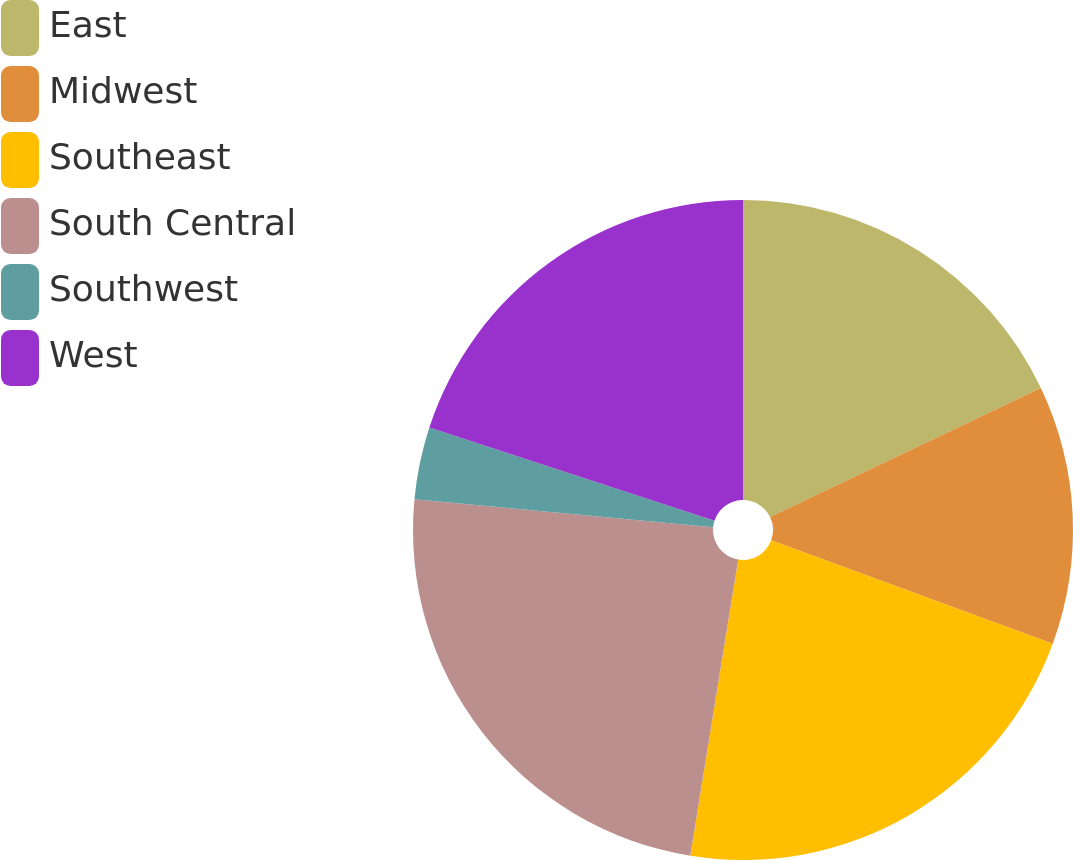Convert chart to OTSL. <chart><loc_0><loc_0><loc_500><loc_500><pie_chart><fcel>East<fcel>Midwest<fcel>Southeast<fcel>South Central<fcel>Southwest<fcel>West<nl><fcel>17.92%<fcel>12.69%<fcel>21.95%<fcel>23.93%<fcel>3.55%<fcel>19.97%<nl></chart> 